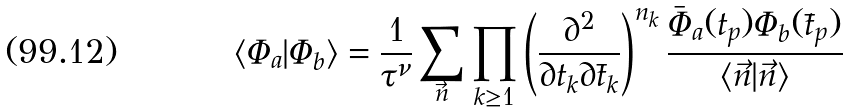<formula> <loc_0><loc_0><loc_500><loc_500>\langle \Phi _ { a } | \Phi _ { b } \rangle = \frac { 1 } { \tau ^ { \nu } } \sum _ { \vec { n } } \prod _ { k \geq 1 } \left ( \frac { \partial ^ { 2 } } { \partial t _ { k } \partial \bar { t } _ { k } } \right ) ^ { n _ { k } } \frac { \bar { \Phi } _ { a } ( t _ { p } ) \Phi _ { b } ( \bar { t } _ { p } ) } { \langle \vec { n } | \vec { n } \rangle }</formula> 